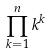Convert formula to latex. <formula><loc_0><loc_0><loc_500><loc_500>\prod _ { k = 1 } ^ { n } k ^ { k }</formula> 